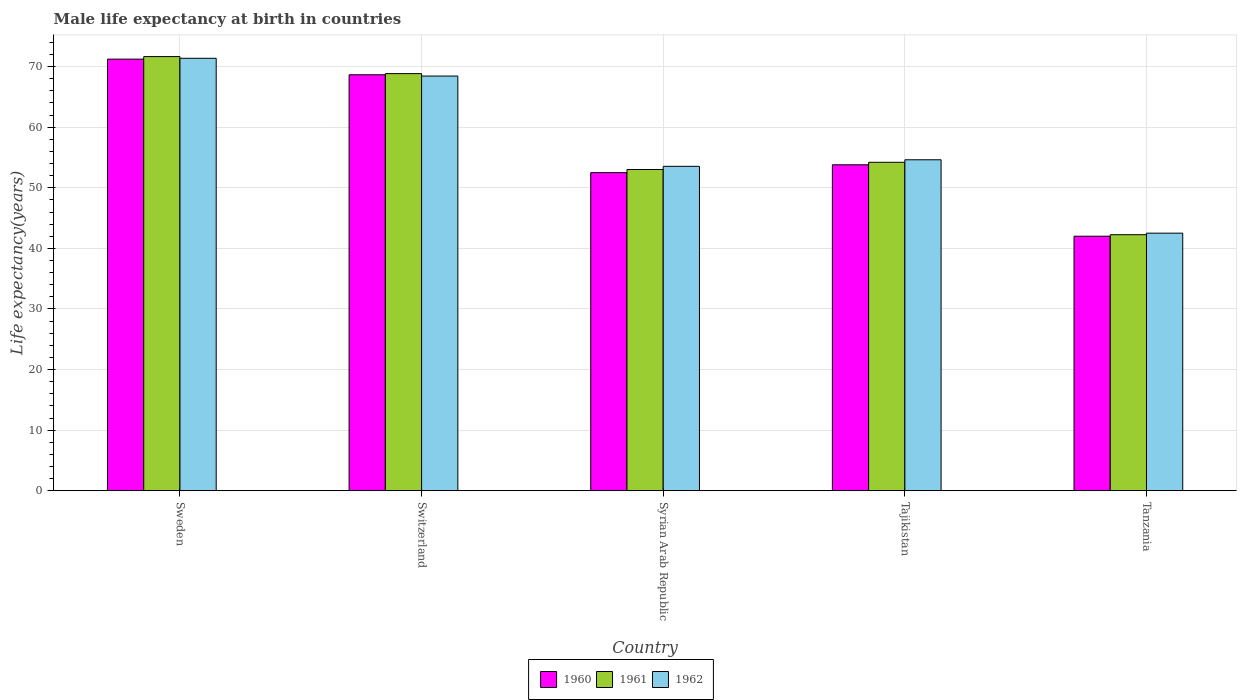How many bars are there on the 5th tick from the left?
Provide a short and direct response. 3. How many bars are there on the 3rd tick from the right?
Offer a terse response. 3. What is the male life expectancy at birth in 1962 in Sweden?
Keep it short and to the point. 71.37. Across all countries, what is the maximum male life expectancy at birth in 1961?
Give a very brief answer. 71.65. Across all countries, what is the minimum male life expectancy at birth in 1962?
Offer a very short reply. 42.51. In which country was the male life expectancy at birth in 1960 minimum?
Give a very brief answer. Tanzania. What is the total male life expectancy at birth in 1961 in the graph?
Your answer should be very brief. 289.97. What is the difference between the male life expectancy at birth in 1962 in Tajikistan and that in Tanzania?
Make the answer very short. 12.11. What is the difference between the male life expectancy at birth in 1962 in Sweden and the male life expectancy at birth in 1960 in Tajikistan?
Give a very brief answer. 17.58. What is the average male life expectancy at birth in 1962 per country?
Your response must be concise. 58.1. In how many countries, is the male life expectancy at birth in 1960 greater than 18 years?
Ensure brevity in your answer.  5. What is the ratio of the male life expectancy at birth in 1961 in Switzerland to that in Tajikistan?
Your answer should be very brief. 1.27. Is the male life expectancy at birth in 1962 in Sweden less than that in Syrian Arab Republic?
Make the answer very short. No. Is the difference between the male life expectancy at birth in 1960 in Sweden and Syrian Arab Republic greater than the difference between the male life expectancy at birth in 1961 in Sweden and Syrian Arab Republic?
Your answer should be compact. Yes. What is the difference between the highest and the second highest male life expectancy at birth in 1961?
Your answer should be compact. 14.63. What is the difference between the highest and the lowest male life expectancy at birth in 1962?
Make the answer very short. 28.86. In how many countries, is the male life expectancy at birth in 1961 greater than the average male life expectancy at birth in 1961 taken over all countries?
Your answer should be very brief. 2. Is the sum of the male life expectancy at birth in 1960 in Syrian Arab Republic and Tanzania greater than the maximum male life expectancy at birth in 1962 across all countries?
Provide a short and direct response. Yes. What does the 2nd bar from the left in Tanzania represents?
Your answer should be compact. 1961. What does the 2nd bar from the right in Tajikistan represents?
Your response must be concise. 1961. How many countries are there in the graph?
Ensure brevity in your answer.  5. Does the graph contain any zero values?
Keep it short and to the point. No. Does the graph contain grids?
Offer a very short reply. Yes. How many legend labels are there?
Keep it short and to the point. 3. What is the title of the graph?
Ensure brevity in your answer.  Male life expectancy at birth in countries. What is the label or title of the X-axis?
Offer a terse response. Country. What is the label or title of the Y-axis?
Your answer should be very brief. Life expectancy(years). What is the Life expectancy(years) of 1960 in Sweden?
Your answer should be very brief. 71.23. What is the Life expectancy(years) in 1961 in Sweden?
Make the answer very short. 71.65. What is the Life expectancy(years) in 1962 in Sweden?
Offer a terse response. 71.37. What is the Life expectancy(years) in 1960 in Switzerland?
Make the answer very short. 68.65. What is the Life expectancy(years) of 1961 in Switzerland?
Your answer should be very brief. 68.84. What is the Life expectancy(years) in 1962 in Switzerland?
Give a very brief answer. 68.44. What is the Life expectancy(years) in 1960 in Syrian Arab Republic?
Offer a very short reply. 52.5. What is the Life expectancy(years) in 1961 in Syrian Arab Republic?
Your answer should be compact. 53.02. What is the Life expectancy(years) of 1962 in Syrian Arab Republic?
Offer a very short reply. 53.54. What is the Life expectancy(years) of 1960 in Tajikistan?
Make the answer very short. 53.8. What is the Life expectancy(years) of 1961 in Tajikistan?
Give a very brief answer. 54.21. What is the Life expectancy(years) in 1962 in Tajikistan?
Keep it short and to the point. 54.62. What is the Life expectancy(years) in 1960 in Tanzania?
Offer a very short reply. 42.01. What is the Life expectancy(years) of 1961 in Tanzania?
Your response must be concise. 42.26. What is the Life expectancy(years) of 1962 in Tanzania?
Provide a succinct answer. 42.51. Across all countries, what is the maximum Life expectancy(years) of 1960?
Ensure brevity in your answer.  71.23. Across all countries, what is the maximum Life expectancy(years) of 1961?
Offer a very short reply. 71.65. Across all countries, what is the maximum Life expectancy(years) in 1962?
Provide a succinct answer. 71.37. Across all countries, what is the minimum Life expectancy(years) of 1960?
Your answer should be compact. 42.01. Across all countries, what is the minimum Life expectancy(years) of 1961?
Offer a terse response. 42.26. Across all countries, what is the minimum Life expectancy(years) in 1962?
Offer a very short reply. 42.51. What is the total Life expectancy(years) of 1960 in the graph?
Offer a terse response. 288.18. What is the total Life expectancy(years) in 1961 in the graph?
Offer a terse response. 289.97. What is the total Life expectancy(years) of 1962 in the graph?
Provide a succinct answer. 290.48. What is the difference between the Life expectancy(years) in 1960 in Sweden and that in Switzerland?
Your answer should be compact. 2.58. What is the difference between the Life expectancy(years) in 1961 in Sweden and that in Switzerland?
Your answer should be compact. 2.81. What is the difference between the Life expectancy(years) of 1962 in Sweden and that in Switzerland?
Make the answer very short. 2.93. What is the difference between the Life expectancy(years) of 1960 in Sweden and that in Syrian Arab Republic?
Give a very brief answer. 18.73. What is the difference between the Life expectancy(years) in 1961 in Sweden and that in Syrian Arab Republic?
Your answer should be very brief. 18.64. What is the difference between the Life expectancy(years) in 1962 in Sweden and that in Syrian Arab Republic?
Provide a succinct answer. 17.83. What is the difference between the Life expectancy(years) in 1960 in Sweden and that in Tajikistan?
Provide a succinct answer. 17.43. What is the difference between the Life expectancy(years) of 1961 in Sweden and that in Tajikistan?
Ensure brevity in your answer.  17.44. What is the difference between the Life expectancy(years) in 1962 in Sweden and that in Tajikistan?
Ensure brevity in your answer.  16.75. What is the difference between the Life expectancy(years) of 1960 in Sweden and that in Tanzania?
Keep it short and to the point. 29.22. What is the difference between the Life expectancy(years) of 1961 in Sweden and that in Tanzania?
Provide a succinct answer. 29.39. What is the difference between the Life expectancy(years) in 1962 in Sweden and that in Tanzania?
Offer a terse response. 28.86. What is the difference between the Life expectancy(years) in 1960 in Switzerland and that in Syrian Arab Republic?
Your answer should be very brief. 16.15. What is the difference between the Life expectancy(years) of 1961 in Switzerland and that in Syrian Arab Republic?
Offer a very short reply. 15.82. What is the difference between the Life expectancy(years) of 1962 in Switzerland and that in Syrian Arab Republic?
Give a very brief answer. 14.9. What is the difference between the Life expectancy(years) in 1960 in Switzerland and that in Tajikistan?
Offer a terse response. 14.86. What is the difference between the Life expectancy(years) in 1961 in Switzerland and that in Tajikistan?
Provide a short and direct response. 14.63. What is the difference between the Life expectancy(years) in 1962 in Switzerland and that in Tajikistan?
Offer a terse response. 13.82. What is the difference between the Life expectancy(years) of 1960 in Switzerland and that in Tanzania?
Give a very brief answer. 26.64. What is the difference between the Life expectancy(years) of 1961 in Switzerland and that in Tanzania?
Your answer should be compact. 26.58. What is the difference between the Life expectancy(years) of 1962 in Switzerland and that in Tanzania?
Your response must be concise. 25.93. What is the difference between the Life expectancy(years) of 1960 in Syrian Arab Republic and that in Tajikistan?
Your answer should be compact. -1.3. What is the difference between the Life expectancy(years) of 1961 in Syrian Arab Republic and that in Tajikistan?
Offer a terse response. -1.19. What is the difference between the Life expectancy(years) of 1962 in Syrian Arab Republic and that in Tajikistan?
Offer a very short reply. -1.08. What is the difference between the Life expectancy(years) in 1960 in Syrian Arab Republic and that in Tanzania?
Give a very brief answer. 10.49. What is the difference between the Life expectancy(years) of 1961 in Syrian Arab Republic and that in Tanzania?
Give a very brief answer. 10.76. What is the difference between the Life expectancy(years) in 1962 in Syrian Arab Republic and that in Tanzania?
Provide a short and direct response. 11.03. What is the difference between the Life expectancy(years) of 1960 in Tajikistan and that in Tanzania?
Offer a very short reply. 11.79. What is the difference between the Life expectancy(years) of 1961 in Tajikistan and that in Tanzania?
Your response must be concise. 11.95. What is the difference between the Life expectancy(years) of 1962 in Tajikistan and that in Tanzania?
Ensure brevity in your answer.  12.11. What is the difference between the Life expectancy(years) in 1960 in Sweden and the Life expectancy(years) in 1961 in Switzerland?
Your response must be concise. 2.39. What is the difference between the Life expectancy(years) in 1960 in Sweden and the Life expectancy(years) in 1962 in Switzerland?
Keep it short and to the point. 2.79. What is the difference between the Life expectancy(years) of 1961 in Sweden and the Life expectancy(years) of 1962 in Switzerland?
Make the answer very short. 3.21. What is the difference between the Life expectancy(years) of 1960 in Sweden and the Life expectancy(years) of 1961 in Syrian Arab Republic?
Give a very brief answer. 18.21. What is the difference between the Life expectancy(years) in 1960 in Sweden and the Life expectancy(years) in 1962 in Syrian Arab Republic?
Offer a terse response. 17.69. What is the difference between the Life expectancy(years) of 1961 in Sweden and the Life expectancy(years) of 1962 in Syrian Arab Republic?
Offer a very short reply. 18.11. What is the difference between the Life expectancy(years) of 1960 in Sweden and the Life expectancy(years) of 1961 in Tajikistan?
Your response must be concise. 17.02. What is the difference between the Life expectancy(years) of 1960 in Sweden and the Life expectancy(years) of 1962 in Tajikistan?
Provide a succinct answer. 16.61. What is the difference between the Life expectancy(years) in 1961 in Sweden and the Life expectancy(years) in 1962 in Tajikistan?
Your answer should be very brief. 17.03. What is the difference between the Life expectancy(years) of 1960 in Sweden and the Life expectancy(years) of 1961 in Tanzania?
Provide a succinct answer. 28.97. What is the difference between the Life expectancy(years) in 1960 in Sweden and the Life expectancy(years) in 1962 in Tanzania?
Make the answer very short. 28.72. What is the difference between the Life expectancy(years) in 1961 in Sweden and the Life expectancy(years) in 1962 in Tanzania?
Provide a succinct answer. 29.14. What is the difference between the Life expectancy(years) of 1960 in Switzerland and the Life expectancy(years) of 1961 in Syrian Arab Republic?
Your answer should be compact. 15.63. What is the difference between the Life expectancy(years) of 1960 in Switzerland and the Life expectancy(years) of 1962 in Syrian Arab Republic?
Make the answer very short. 15.11. What is the difference between the Life expectancy(years) of 1961 in Switzerland and the Life expectancy(years) of 1962 in Syrian Arab Republic?
Your response must be concise. 15.3. What is the difference between the Life expectancy(years) in 1960 in Switzerland and the Life expectancy(years) in 1961 in Tajikistan?
Keep it short and to the point. 14.44. What is the difference between the Life expectancy(years) in 1960 in Switzerland and the Life expectancy(years) in 1962 in Tajikistan?
Ensure brevity in your answer.  14.03. What is the difference between the Life expectancy(years) of 1961 in Switzerland and the Life expectancy(years) of 1962 in Tajikistan?
Offer a terse response. 14.22. What is the difference between the Life expectancy(years) in 1960 in Switzerland and the Life expectancy(years) in 1961 in Tanzania?
Your answer should be very brief. 26.39. What is the difference between the Life expectancy(years) in 1960 in Switzerland and the Life expectancy(years) in 1962 in Tanzania?
Make the answer very short. 26.14. What is the difference between the Life expectancy(years) in 1961 in Switzerland and the Life expectancy(years) in 1962 in Tanzania?
Keep it short and to the point. 26.33. What is the difference between the Life expectancy(years) of 1960 in Syrian Arab Republic and the Life expectancy(years) of 1961 in Tajikistan?
Your answer should be very brief. -1.71. What is the difference between the Life expectancy(years) of 1960 in Syrian Arab Republic and the Life expectancy(years) of 1962 in Tajikistan?
Your answer should be very brief. -2.12. What is the difference between the Life expectancy(years) in 1961 in Syrian Arab Republic and the Life expectancy(years) in 1962 in Tajikistan?
Keep it short and to the point. -1.61. What is the difference between the Life expectancy(years) in 1960 in Syrian Arab Republic and the Life expectancy(years) in 1961 in Tanzania?
Offer a terse response. 10.24. What is the difference between the Life expectancy(years) in 1960 in Syrian Arab Republic and the Life expectancy(years) in 1962 in Tanzania?
Ensure brevity in your answer.  9.99. What is the difference between the Life expectancy(years) in 1961 in Syrian Arab Republic and the Life expectancy(years) in 1962 in Tanzania?
Your response must be concise. 10.5. What is the difference between the Life expectancy(years) of 1960 in Tajikistan and the Life expectancy(years) of 1961 in Tanzania?
Your answer should be compact. 11.54. What is the difference between the Life expectancy(years) in 1960 in Tajikistan and the Life expectancy(years) in 1962 in Tanzania?
Provide a short and direct response. 11.28. What is the difference between the Life expectancy(years) in 1961 in Tajikistan and the Life expectancy(years) in 1962 in Tanzania?
Give a very brief answer. 11.7. What is the average Life expectancy(years) of 1960 per country?
Offer a very short reply. 57.64. What is the average Life expectancy(years) in 1961 per country?
Provide a succinct answer. 57.99. What is the average Life expectancy(years) of 1962 per country?
Your answer should be very brief. 58.1. What is the difference between the Life expectancy(years) in 1960 and Life expectancy(years) in 1961 in Sweden?
Offer a very short reply. -0.42. What is the difference between the Life expectancy(years) of 1960 and Life expectancy(years) of 1962 in Sweden?
Ensure brevity in your answer.  -0.14. What is the difference between the Life expectancy(years) of 1961 and Life expectancy(years) of 1962 in Sweden?
Give a very brief answer. 0.28. What is the difference between the Life expectancy(years) of 1960 and Life expectancy(years) of 1961 in Switzerland?
Provide a short and direct response. -0.19. What is the difference between the Life expectancy(years) of 1960 and Life expectancy(years) of 1962 in Switzerland?
Your response must be concise. 0.21. What is the difference between the Life expectancy(years) in 1960 and Life expectancy(years) in 1961 in Syrian Arab Republic?
Provide a succinct answer. -0.52. What is the difference between the Life expectancy(years) of 1960 and Life expectancy(years) of 1962 in Syrian Arab Republic?
Your answer should be compact. -1.04. What is the difference between the Life expectancy(years) of 1961 and Life expectancy(years) of 1962 in Syrian Arab Republic?
Ensure brevity in your answer.  -0.53. What is the difference between the Life expectancy(years) in 1960 and Life expectancy(years) in 1961 in Tajikistan?
Offer a very short reply. -0.41. What is the difference between the Life expectancy(years) of 1960 and Life expectancy(years) of 1962 in Tajikistan?
Your answer should be very brief. -0.83. What is the difference between the Life expectancy(years) in 1961 and Life expectancy(years) in 1962 in Tajikistan?
Provide a succinct answer. -0.41. What is the difference between the Life expectancy(years) in 1960 and Life expectancy(years) in 1961 in Tanzania?
Make the answer very short. -0.25. What is the difference between the Life expectancy(years) in 1960 and Life expectancy(years) in 1962 in Tanzania?
Keep it short and to the point. -0.5. What is the difference between the Life expectancy(years) in 1961 and Life expectancy(years) in 1962 in Tanzania?
Make the answer very short. -0.25. What is the ratio of the Life expectancy(years) of 1960 in Sweden to that in Switzerland?
Offer a very short reply. 1.04. What is the ratio of the Life expectancy(years) in 1961 in Sweden to that in Switzerland?
Ensure brevity in your answer.  1.04. What is the ratio of the Life expectancy(years) in 1962 in Sweden to that in Switzerland?
Provide a short and direct response. 1.04. What is the ratio of the Life expectancy(years) in 1960 in Sweden to that in Syrian Arab Republic?
Provide a succinct answer. 1.36. What is the ratio of the Life expectancy(years) of 1961 in Sweden to that in Syrian Arab Republic?
Ensure brevity in your answer.  1.35. What is the ratio of the Life expectancy(years) in 1962 in Sweden to that in Syrian Arab Republic?
Your response must be concise. 1.33. What is the ratio of the Life expectancy(years) of 1960 in Sweden to that in Tajikistan?
Your answer should be compact. 1.32. What is the ratio of the Life expectancy(years) in 1961 in Sweden to that in Tajikistan?
Offer a terse response. 1.32. What is the ratio of the Life expectancy(years) in 1962 in Sweden to that in Tajikistan?
Offer a terse response. 1.31. What is the ratio of the Life expectancy(years) in 1960 in Sweden to that in Tanzania?
Ensure brevity in your answer.  1.7. What is the ratio of the Life expectancy(years) of 1961 in Sweden to that in Tanzania?
Provide a succinct answer. 1.7. What is the ratio of the Life expectancy(years) of 1962 in Sweden to that in Tanzania?
Ensure brevity in your answer.  1.68. What is the ratio of the Life expectancy(years) of 1960 in Switzerland to that in Syrian Arab Republic?
Make the answer very short. 1.31. What is the ratio of the Life expectancy(years) in 1961 in Switzerland to that in Syrian Arab Republic?
Make the answer very short. 1.3. What is the ratio of the Life expectancy(years) of 1962 in Switzerland to that in Syrian Arab Republic?
Your answer should be compact. 1.28. What is the ratio of the Life expectancy(years) of 1960 in Switzerland to that in Tajikistan?
Keep it short and to the point. 1.28. What is the ratio of the Life expectancy(years) in 1961 in Switzerland to that in Tajikistan?
Provide a succinct answer. 1.27. What is the ratio of the Life expectancy(years) of 1962 in Switzerland to that in Tajikistan?
Your answer should be very brief. 1.25. What is the ratio of the Life expectancy(years) of 1960 in Switzerland to that in Tanzania?
Your answer should be very brief. 1.63. What is the ratio of the Life expectancy(years) of 1961 in Switzerland to that in Tanzania?
Keep it short and to the point. 1.63. What is the ratio of the Life expectancy(years) of 1962 in Switzerland to that in Tanzania?
Give a very brief answer. 1.61. What is the ratio of the Life expectancy(years) in 1960 in Syrian Arab Republic to that in Tajikistan?
Your answer should be very brief. 0.98. What is the ratio of the Life expectancy(years) of 1962 in Syrian Arab Republic to that in Tajikistan?
Your answer should be compact. 0.98. What is the ratio of the Life expectancy(years) in 1960 in Syrian Arab Republic to that in Tanzania?
Make the answer very short. 1.25. What is the ratio of the Life expectancy(years) of 1961 in Syrian Arab Republic to that in Tanzania?
Keep it short and to the point. 1.25. What is the ratio of the Life expectancy(years) in 1962 in Syrian Arab Republic to that in Tanzania?
Your answer should be compact. 1.26. What is the ratio of the Life expectancy(years) of 1960 in Tajikistan to that in Tanzania?
Your answer should be compact. 1.28. What is the ratio of the Life expectancy(years) of 1961 in Tajikistan to that in Tanzania?
Provide a succinct answer. 1.28. What is the ratio of the Life expectancy(years) of 1962 in Tajikistan to that in Tanzania?
Make the answer very short. 1.28. What is the difference between the highest and the second highest Life expectancy(years) of 1960?
Offer a very short reply. 2.58. What is the difference between the highest and the second highest Life expectancy(years) in 1961?
Provide a succinct answer. 2.81. What is the difference between the highest and the second highest Life expectancy(years) in 1962?
Make the answer very short. 2.93. What is the difference between the highest and the lowest Life expectancy(years) of 1960?
Offer a terse response. 29.22. What is the difference between the highest and the lowest Life expectancy(years) of 1961?
Your answer should be very brief. 29.39. What is the difference between the highest and the lowest Life expectancy(years) of 1962?
Your answer should be compact. 28.86. 